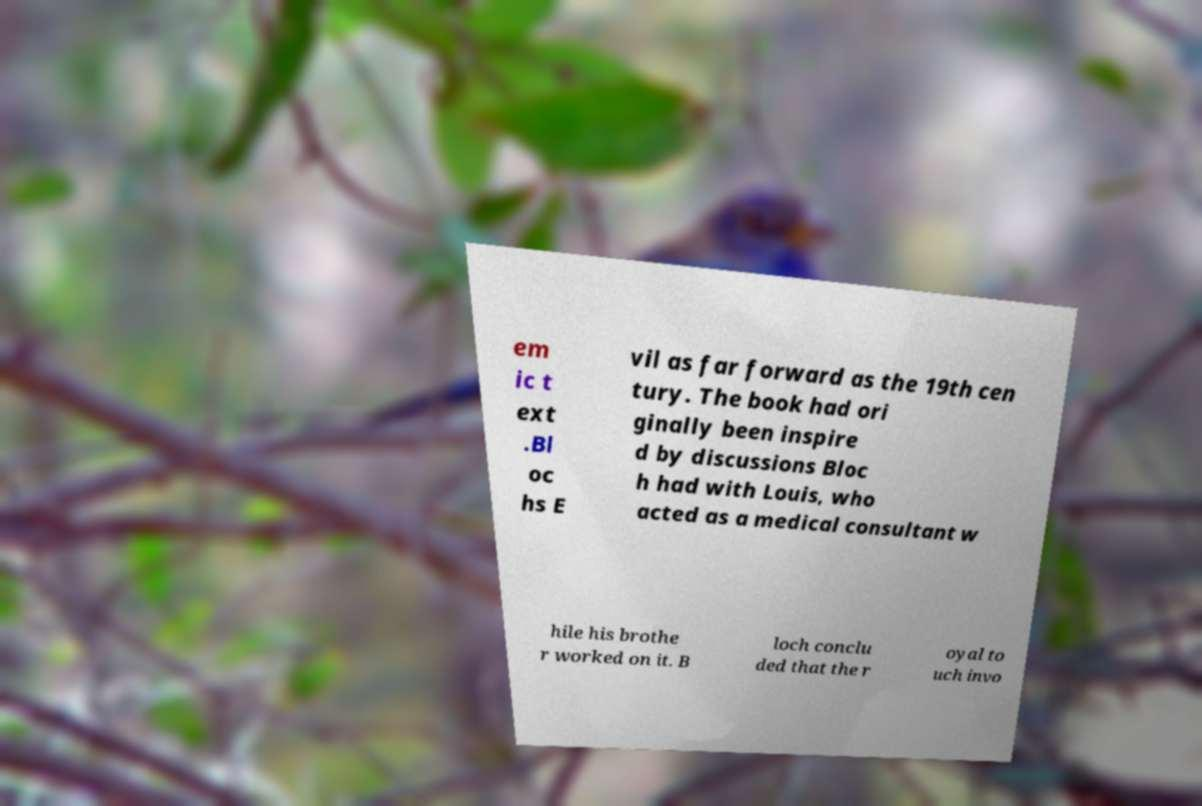Could you extract and type out the text from this image? em ic t ext .Bl oc hs E vil as far forward as the 19th cen tury. The book had ori ginally been inspire d by discussions Bloc h had with Louis, who acted as a medical consultant w hile his brothe r worked on it. B loch conclu ded that the r oyal to uch invo 